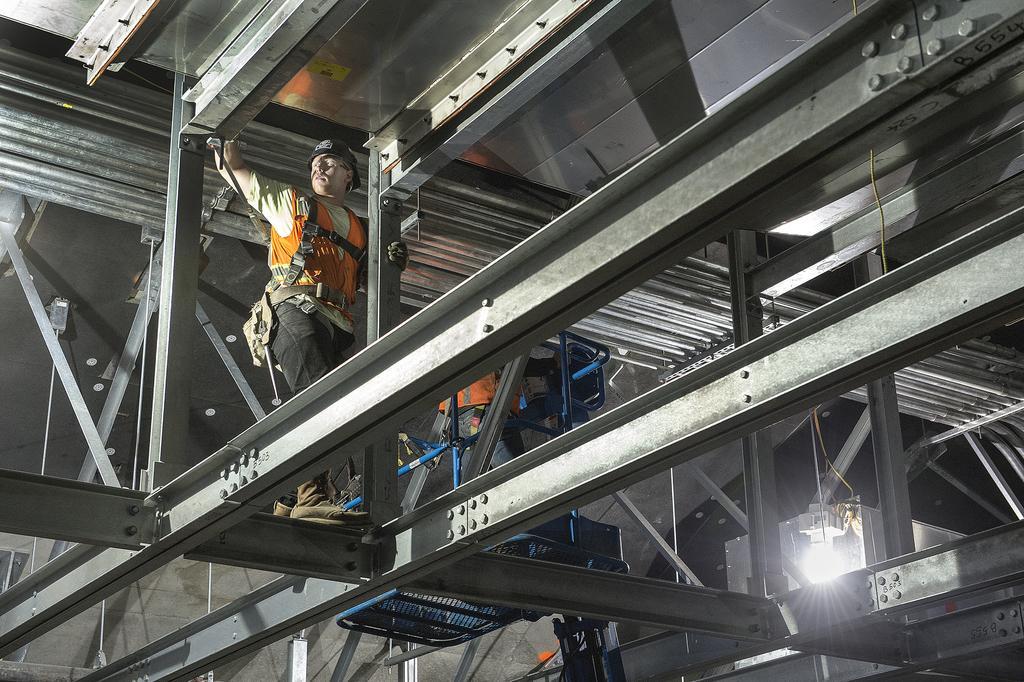Can you describe this image briefly? In the center of the image there are persons standing on the iron bars. On the right side there is a light. In the background there is a wall. 